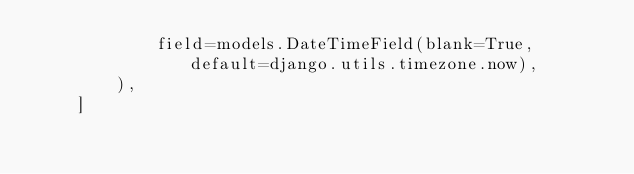Convert code to text. <code><loc_0><loc_0><loc_500><loc_500><_Python_>            field=models.DateTimeField(blank=True, default=django.utils.timezone.now),
        ),
    ]
</code> 